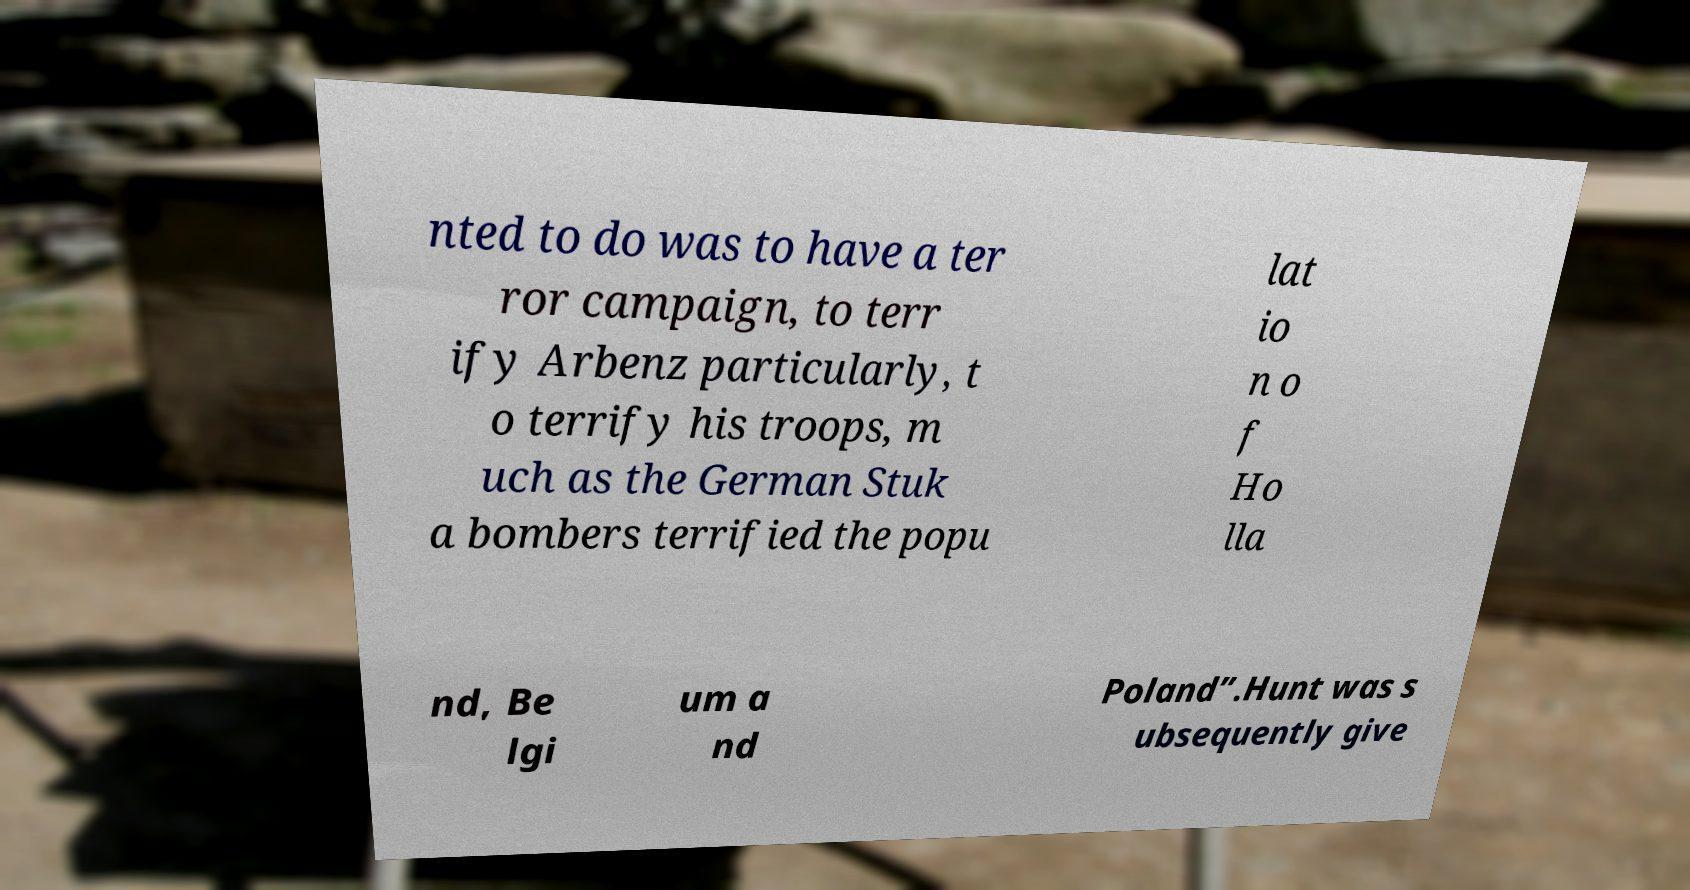Can you read and provide the text displayed in the image?This photo seems to have some interesting text. Can you extract and type it out for me? nted to do was to have a ter ror campaign, to terr ify Arbenz particularly, t o terrify his troops, m uch as the German Stuk a bombers terrified the popu lat io n o f Ho lla nd, Be lgi um a nd Poland”.Hunt was s ubsequently give 